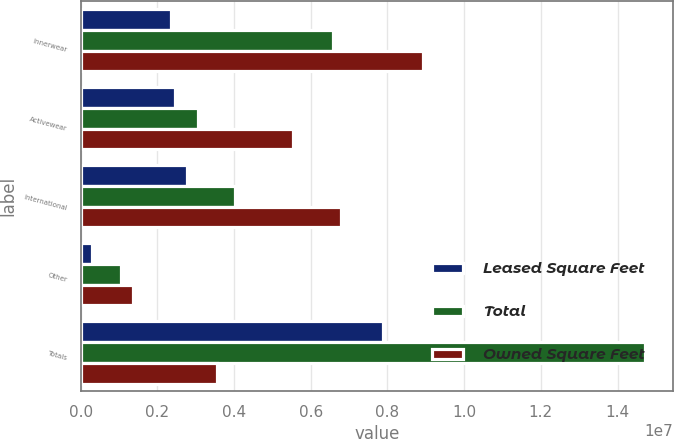Convert chart. <chart><loc_0><loc_0><loc_500><loc_500><stacked_bar_chart><ecel><fcel>Innerwear<fcel>Activewear<fcel>International<fcel>Other<fcel>Totals<nl><fcel>Leased Square Feet<fcel>2.34788e+06<fcel>2.45852e+06<fcel>2.77601e+06<fcel>303445<fcel>7.88586e+06<nl><fcel>Total<fcel>6.5814e+06<fcel>3.06866e+06<fcel>4.01911e+06<fcel>1.05051e+06<fcel>1.47197e+07<nl><fcel>Owned Square Feet<fcel>8.92929e+06<fcel>5.52718e+06<fcel>6.79512e+06<fcel>1.35395e+06<fcel>3.54389e+06<nl></chart> 